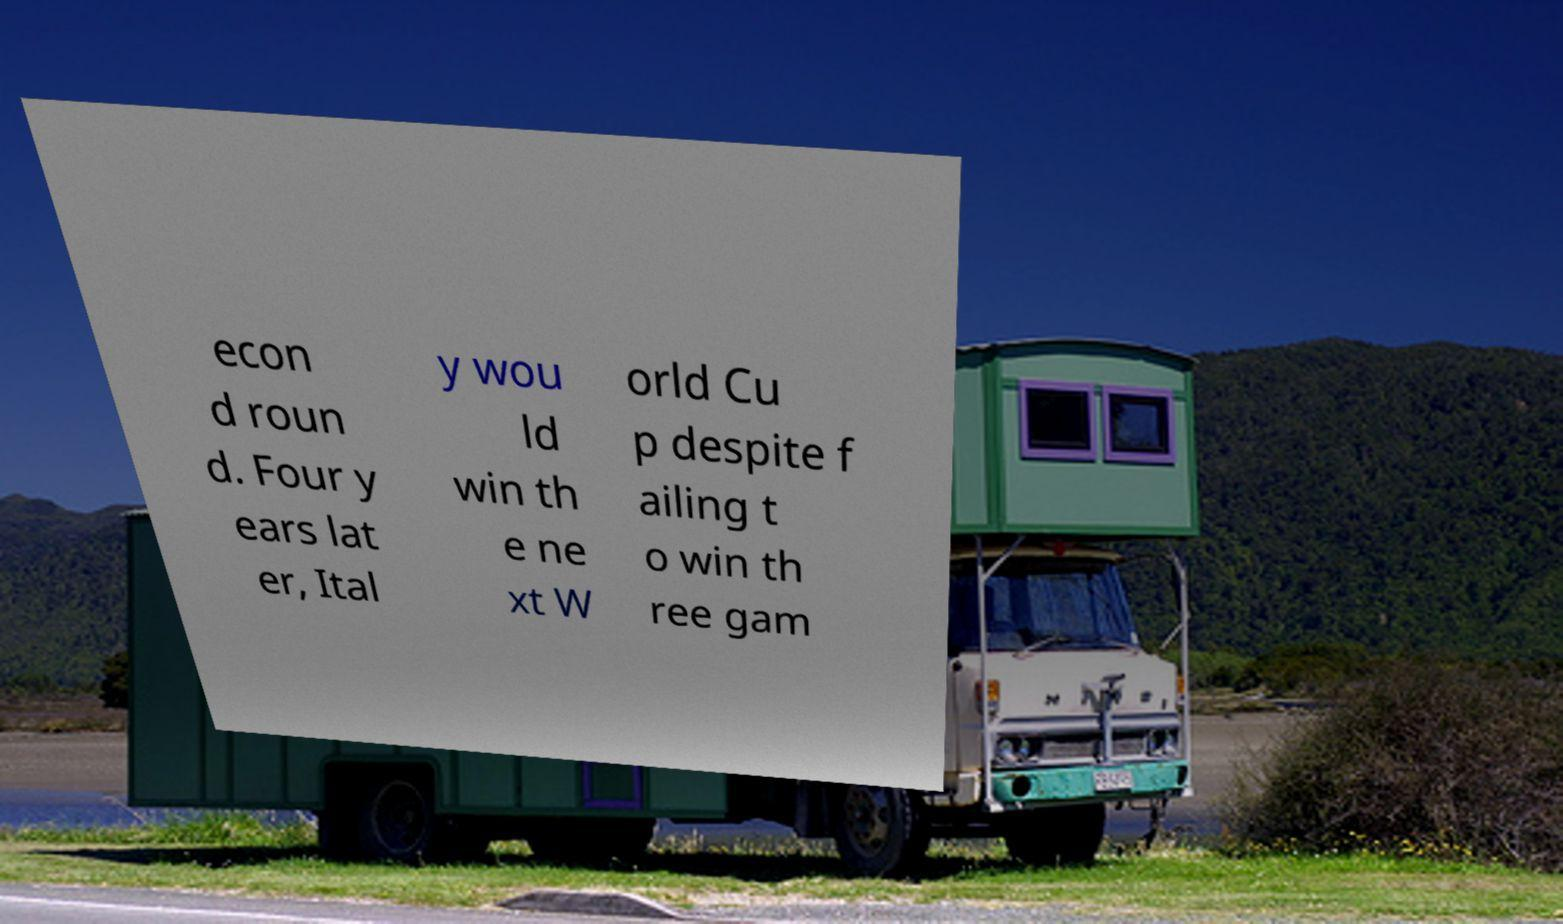Can you accurately transcribe the text from the provided image for me? econ d roun d. Four y ears lat er, Ital y wou ld win th e ne xt W orld Cu p despite f ailing t o win th ree gam 